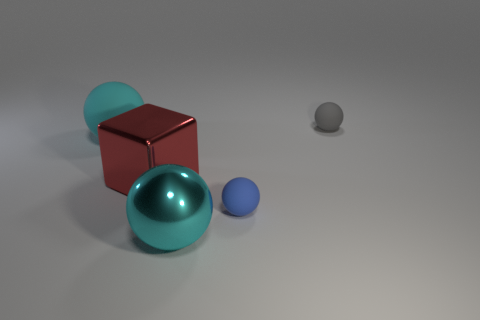Add 5 shiny things. How many objects exist? 10 Subtract all balls. How many objects are left? 1 Add 4 big purple cylinders. How many big purple cylinders exist? 4 Subtract 0 green balls. How many objects are left? 5 Subtract all shiny cubes. Subtract all small spheres. How many objects are left? 2 Add 5 large cyan rubber objects. How many large cyan rubber objects are left? 6 